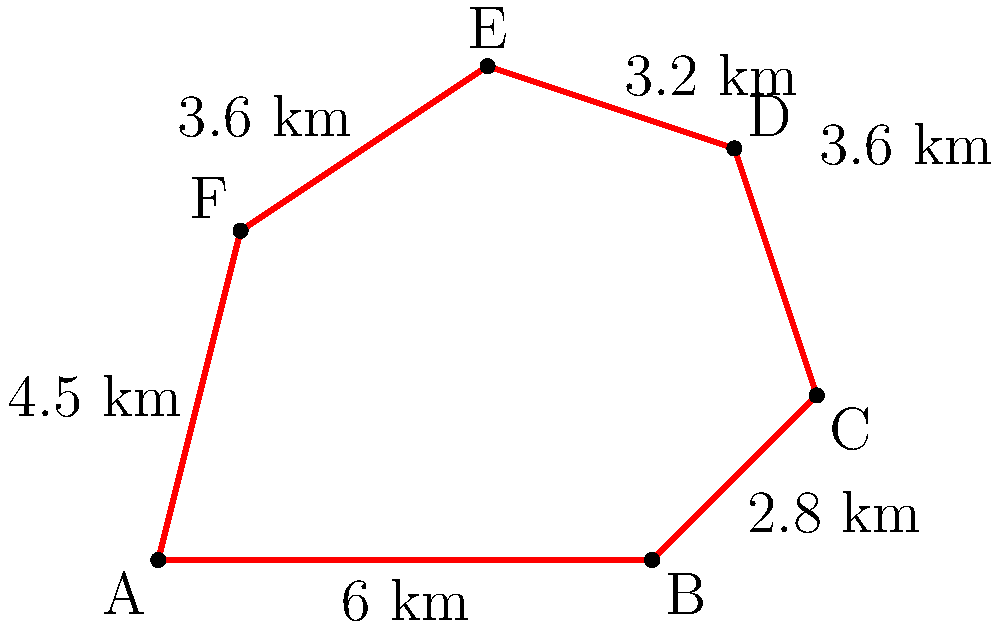As a National Geographic photographer documenting extreme weather phenomena, you've been asked to calculate the perimeter of an irregularly shaped wildfire zone. The fire control team has mapped the zone as a polygon with six vertices (A, B, C, D, E, and F) as shown in the diagram. Given the distances between adjacent vertices, what is the total perimeter of the wildfire zone in kilometers? To find the perimeter of the irregularly shaped wildfire zone, we need to sum up the distances between all adjacent vertices. Let's go through this step-by-step:

1. Distance AB = 6 km
2. Distance BC = 2.8 km
3. Distance CD = 3.6 km
4. Distance DE = 3.2 km
5. Distance EF = 3.6 km
6. Distance FA = 4.5 km

Now, let's add all these distances:

$$ \text{Perimeter} = AB + BC + CD + DE + EF + FA $$
$$ = 6 + 2.8 + 3.6 + 3.2 + 3.6 + 4.5 $$
$$ = 23.7 \text{ km} $$

Therefore, the total perimeter of the wildfire zone is 23.7 kilometers.
Answer: 23.7 km 